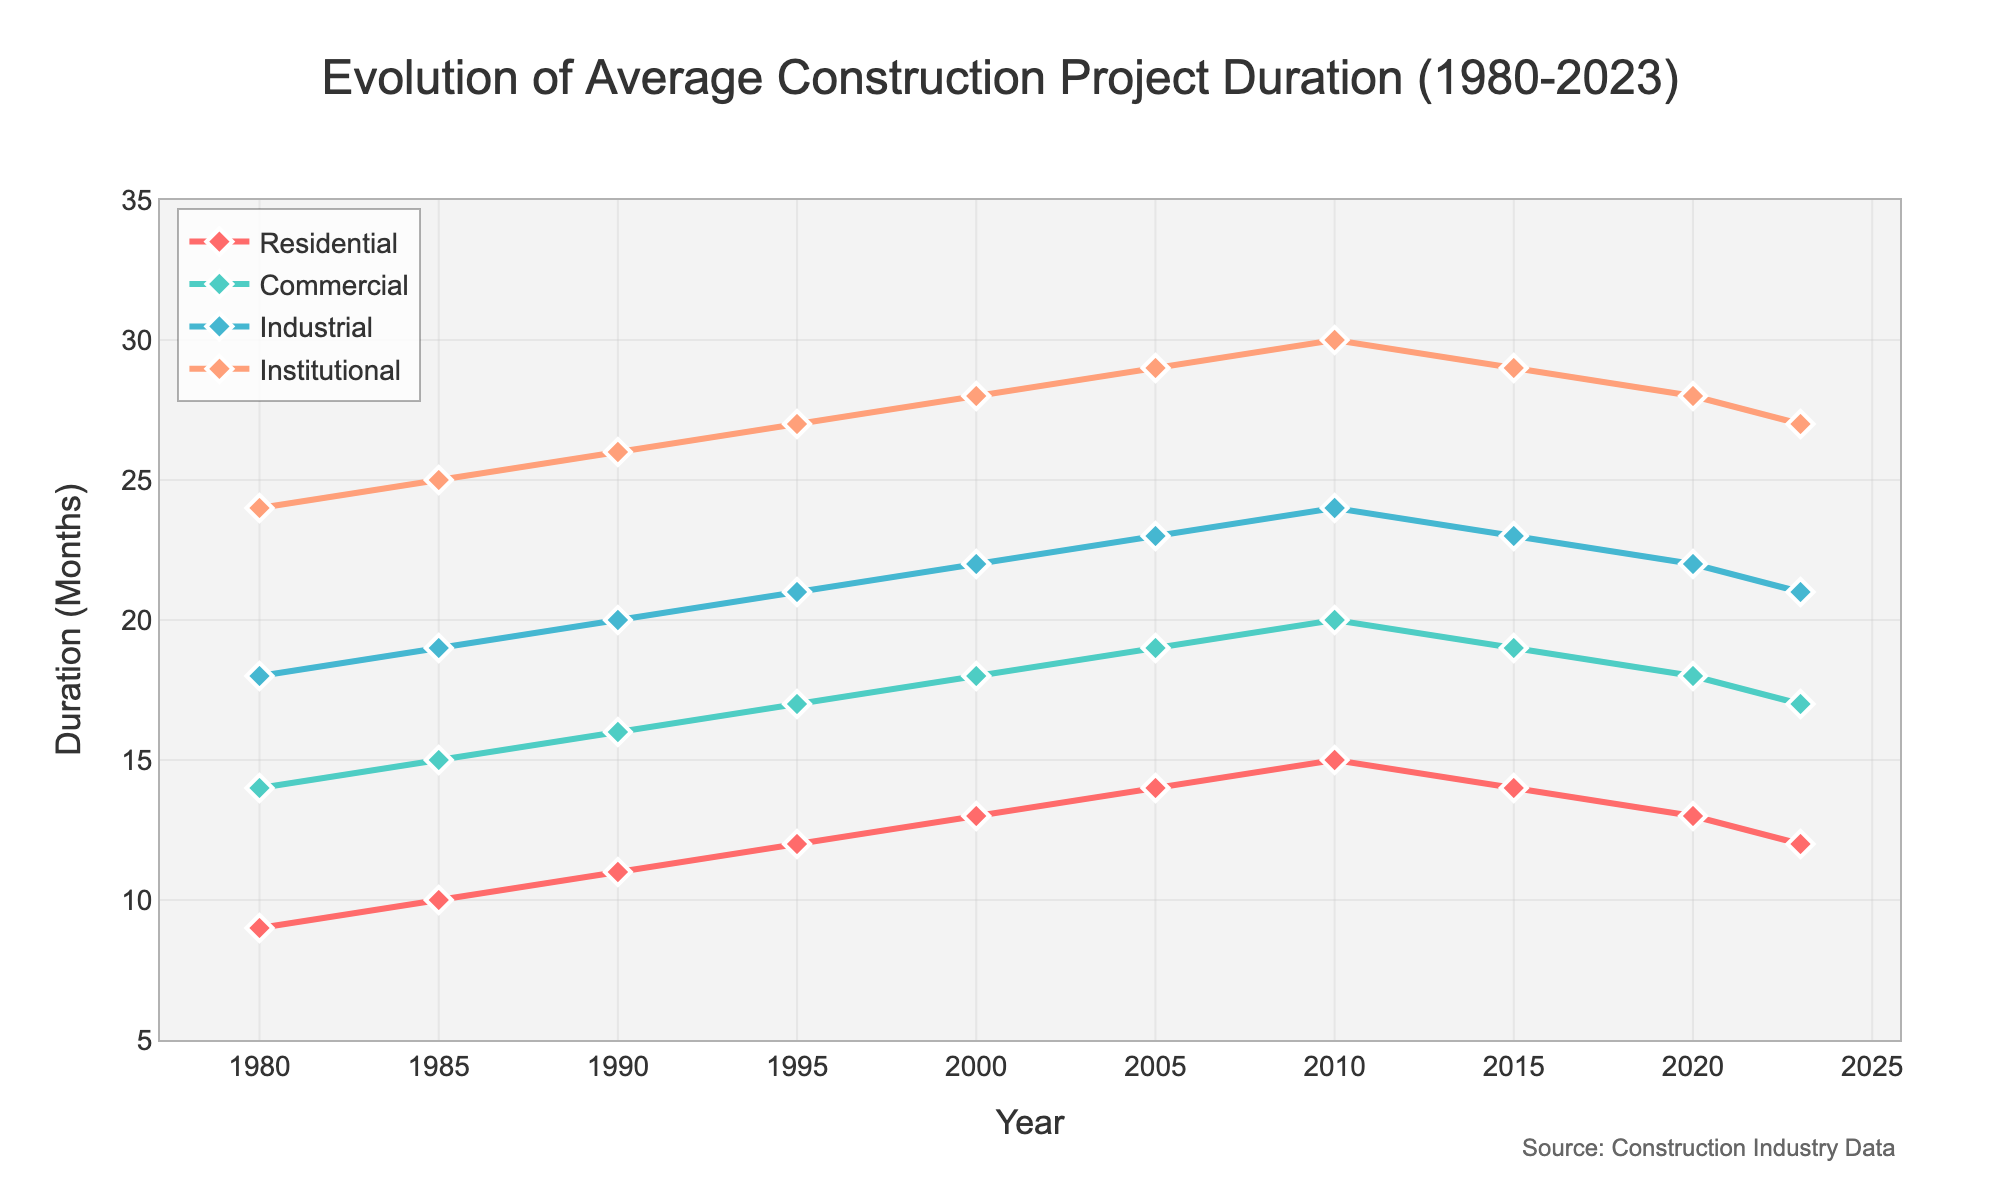What is the trend of the average construction project duration for Residential buildings from 1980 to 2023? The trend for Residential buildings shows an increase from 9 months in 1980 to a peak of 15 months in 2010, followed by a decrease to 12 months in 2023. This indicates that the duration increased steadily for 30 years before starting to decrease.
Answer: Increased until 2010, then decreased Which building type had the highest average project duration in 2020? By comparing the durations for all building types in 2020, Institutional buildings had the highest duration at 28 months.
Answer: Institutional Which year saw the longest average project duration for Industrial buildings? To find the year with the longest duration for Industrial buildings, we need to identify the peak in the Industrial line plot. The highest value for Industrial buildings is 24 months in 2010.
Answer: 2010 What is the difference in the average project duration between Commercial and Residential buildings in 1995? In 1995, the duration for Commercial buildings is 17 months, and for Residential buildings, it is 12 months. The difference is calculated as 17 - 12 = 5 months.
Answer: 5 months By how many months did the average project duration for Institutional buildings change between 1980 and 2023? The duration for Institutional buildings in 1980 is 24 months, and in 2023 it is 27 months. The change is calculated as 27 - 24 = 3 months.
Answer: 3 months Which building type consistently had the shortest average project duration from 1980 to 2023? Comparing the lines for all building types throughout the entire period, Residential buildings consistently had the lowest durations, starting at 9 months in 1980 and ending at 12 months in 2023.
Answer: Residential In which period did the average project duration for Commercial buildings remain constant for the longest time? The Commercial buildings’ duration remained consistent at 19 months from 2005 to 2015. This is the longest period of constant duration observed in the plot.
Answer: 2005-2015 What is the total cumulative change in average project duration for Residential buildings from 1980 to 2023? The duration for Residential buildings increased and then decreased, so we need to sum the cumulative changes: (10-9) + (11-10) + (12-11) + (13-12) + (14-13) + (15-14) + (14-15) + (13-14) + (12-13) = 1 + 1 + 1 + 1 + 1 + 1 - 1 - 1 - 1 = 3 months.
Answer: 3 months Which building type's average project duration peaked at the highest value, and in which year? Observing the peak values of all building types, Institutional buildings had the highest peak at 30 months in the year 2010.
Answer: Institutional, 2010 